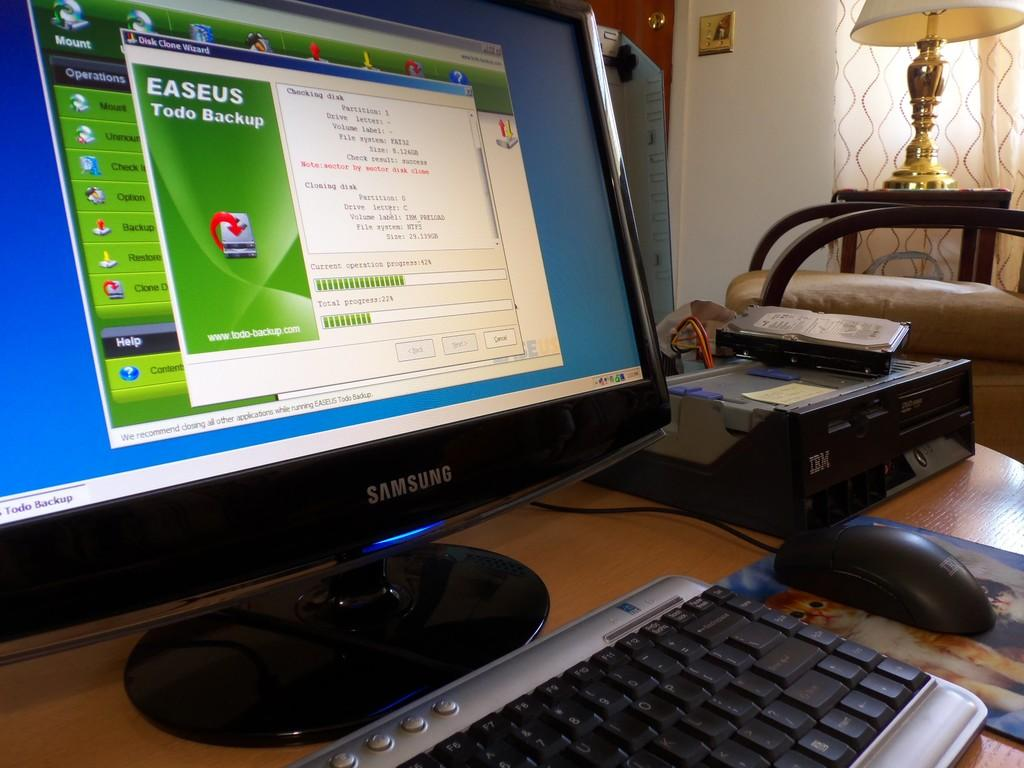<image>
Present a compact description of the photo's key features. A computer that is samsung brand with easeus pulled up on the screen. 